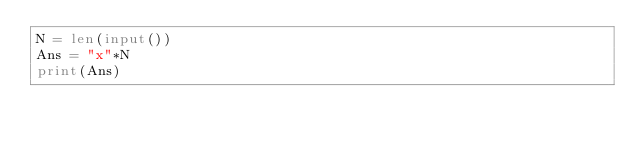Convert code to text. <code><loc_0><loc_0><loc_500><loc_500><_Python_>N = len(input())
Ans = "x"*N
print(Ans)</code> 